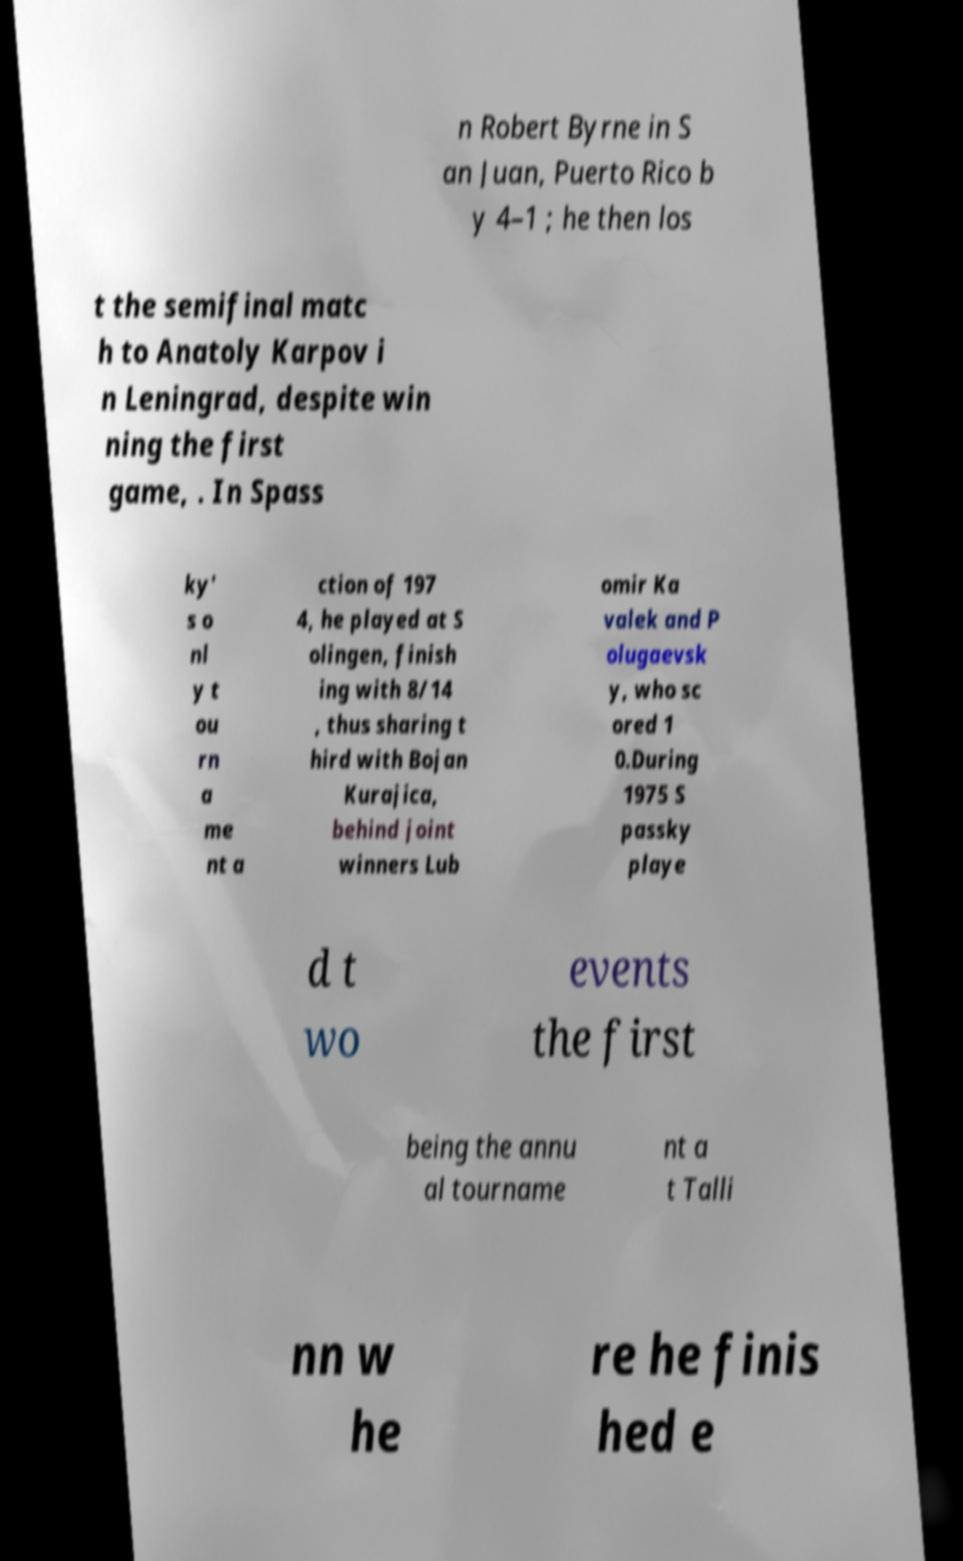What messages or text are displayed in this image? I need them in a readable, typed format. n Robert Byrne in S an Juan, Puerto Rico b y 4–1 ; he then los t the semifinal matc h to Anatoly Karpov i n Leningrad, despite win ning the first game, . In Spass ky' s o nl y t ou rn a me nt a ction of 197 4, he played at S olingen, finish ing with 8/14 , thus sharing t hird with Bojan Kurajica, behind joint winners Lub omir Ka valek and P olugaevsk y, who sc ored 1 0.During 1975 S passky playe d t wo events the first being the annu al tourname nt a t Talli nn w he re he finis hed e 